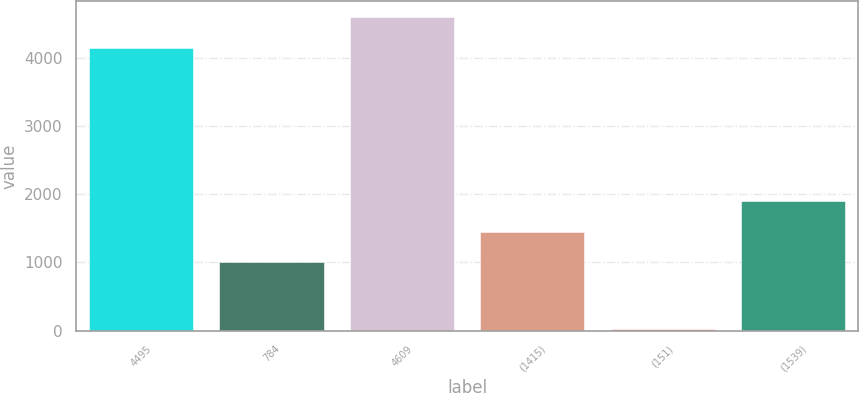Convert chart. <chart><loc_0><loc_0><loc_500><loc_500><bar_chart><fcel>4495<fcel>784<fcel>4609<fcel>(1415)<fcel>(151)<fcel>(1539)<nl><fcel>4159<fcel>1006<fcel>4606.6<fcel>1453.6<fcel>19<fcel>1901.2<nl></chart> 